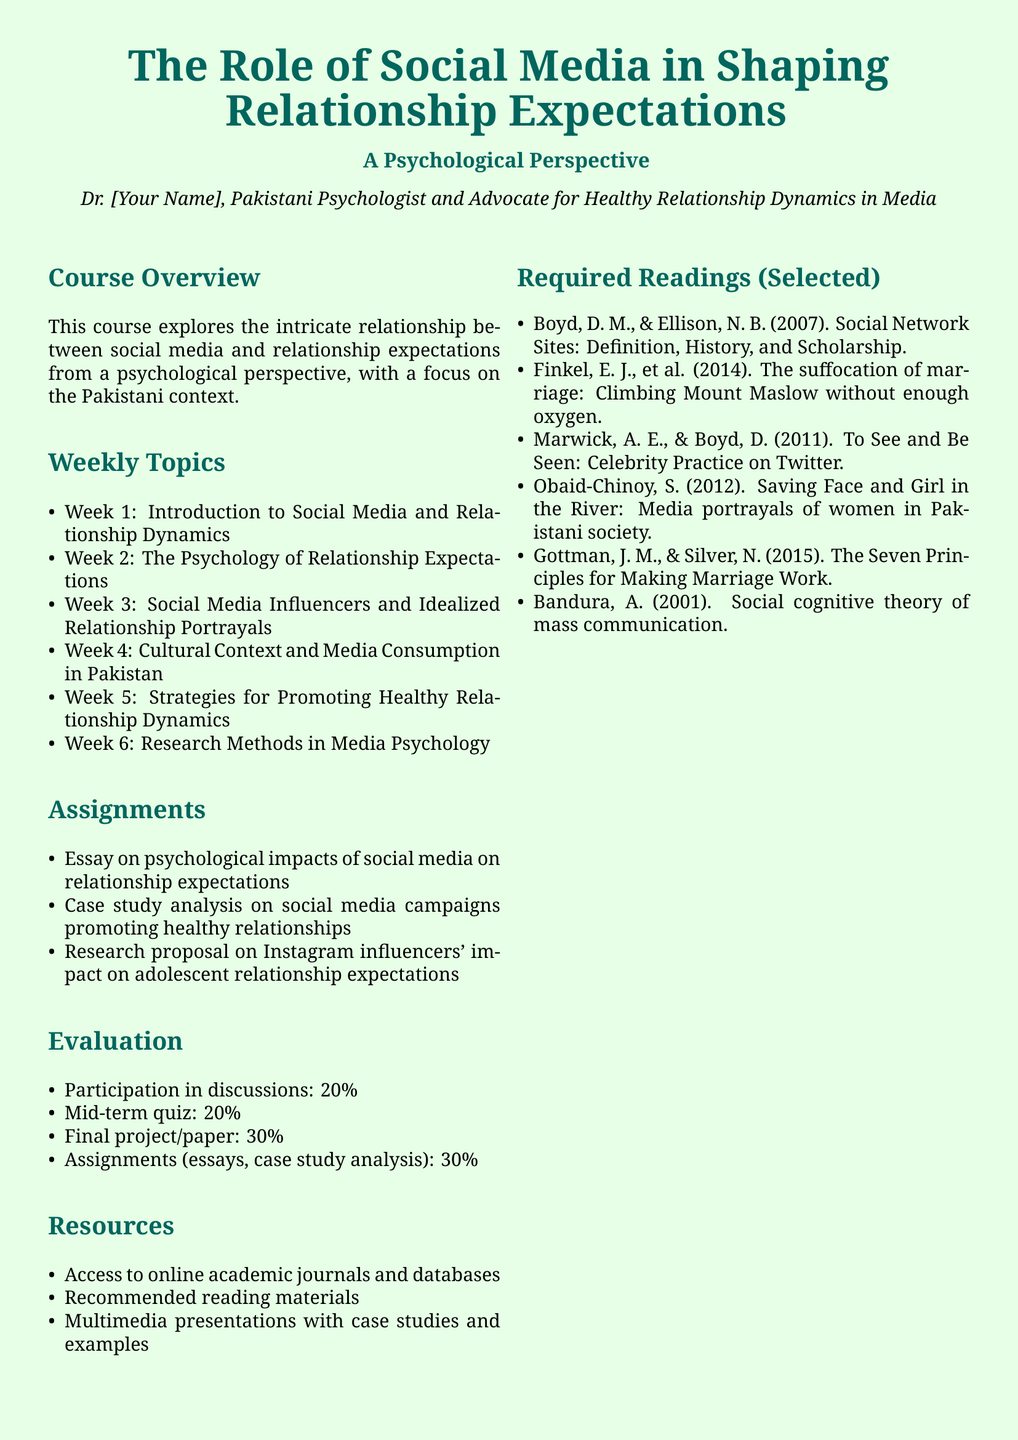What is the title of the course? The title of the course is provided in the document at the beginning, highlighting its focus on social media and relationship expectations.
Answer: The Role of Social Media in Shaping Relationship Expectations Who is the instructor? The document mentions the instructor's title and perspective, including their focus on healthy relationship dynamics within media.
Answer: Dr. [Your Name] How many weeks does the course run? The document lists the weekly topics, indicating the total number of weeks covered in the course.
Answer: 6 weeks What percentage of the evaluation is based on participation in discussions? The evaluation section specifies the weight assigned to each component of the overall evaluation, including participation.
Answer: 20% What is one of the required readings? The document lists several selected required readings for the course curriculum.
Answer: Boyd, D. M., & Ellison, N. B. (2007) Which week focuses on cultural context? The weekly topics outline the specific themes covered each week, including cultural context.
Answer: Week 4 What type of analysis is required as an assignment? The assignment section specifies the types of analyses students are expected to complete for their coursework.
Answer: Case study analysis What are office hours for the instructor? The document explicitly states the designated office hours for student inquiries.
Answer: Tuesdays and Thursdays, 2:00 PM - 4:00 PM 